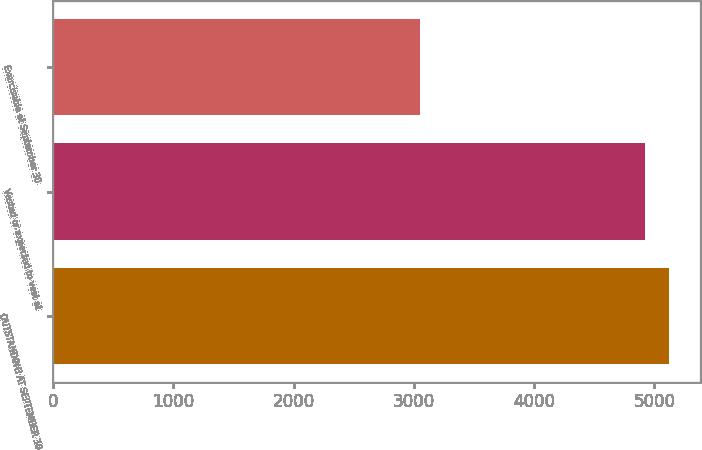<chart> <loc_0><loc_0><loc_500><loc_500><bar_chart><fcel>OUTSTANDING AT SEPTEMBER 30<fcel>Vested or expected to vest at<fcel>Exercisable at September 30<nl><fcel>5122.9<fcel>4918<fcel>3049<nl></chart> 